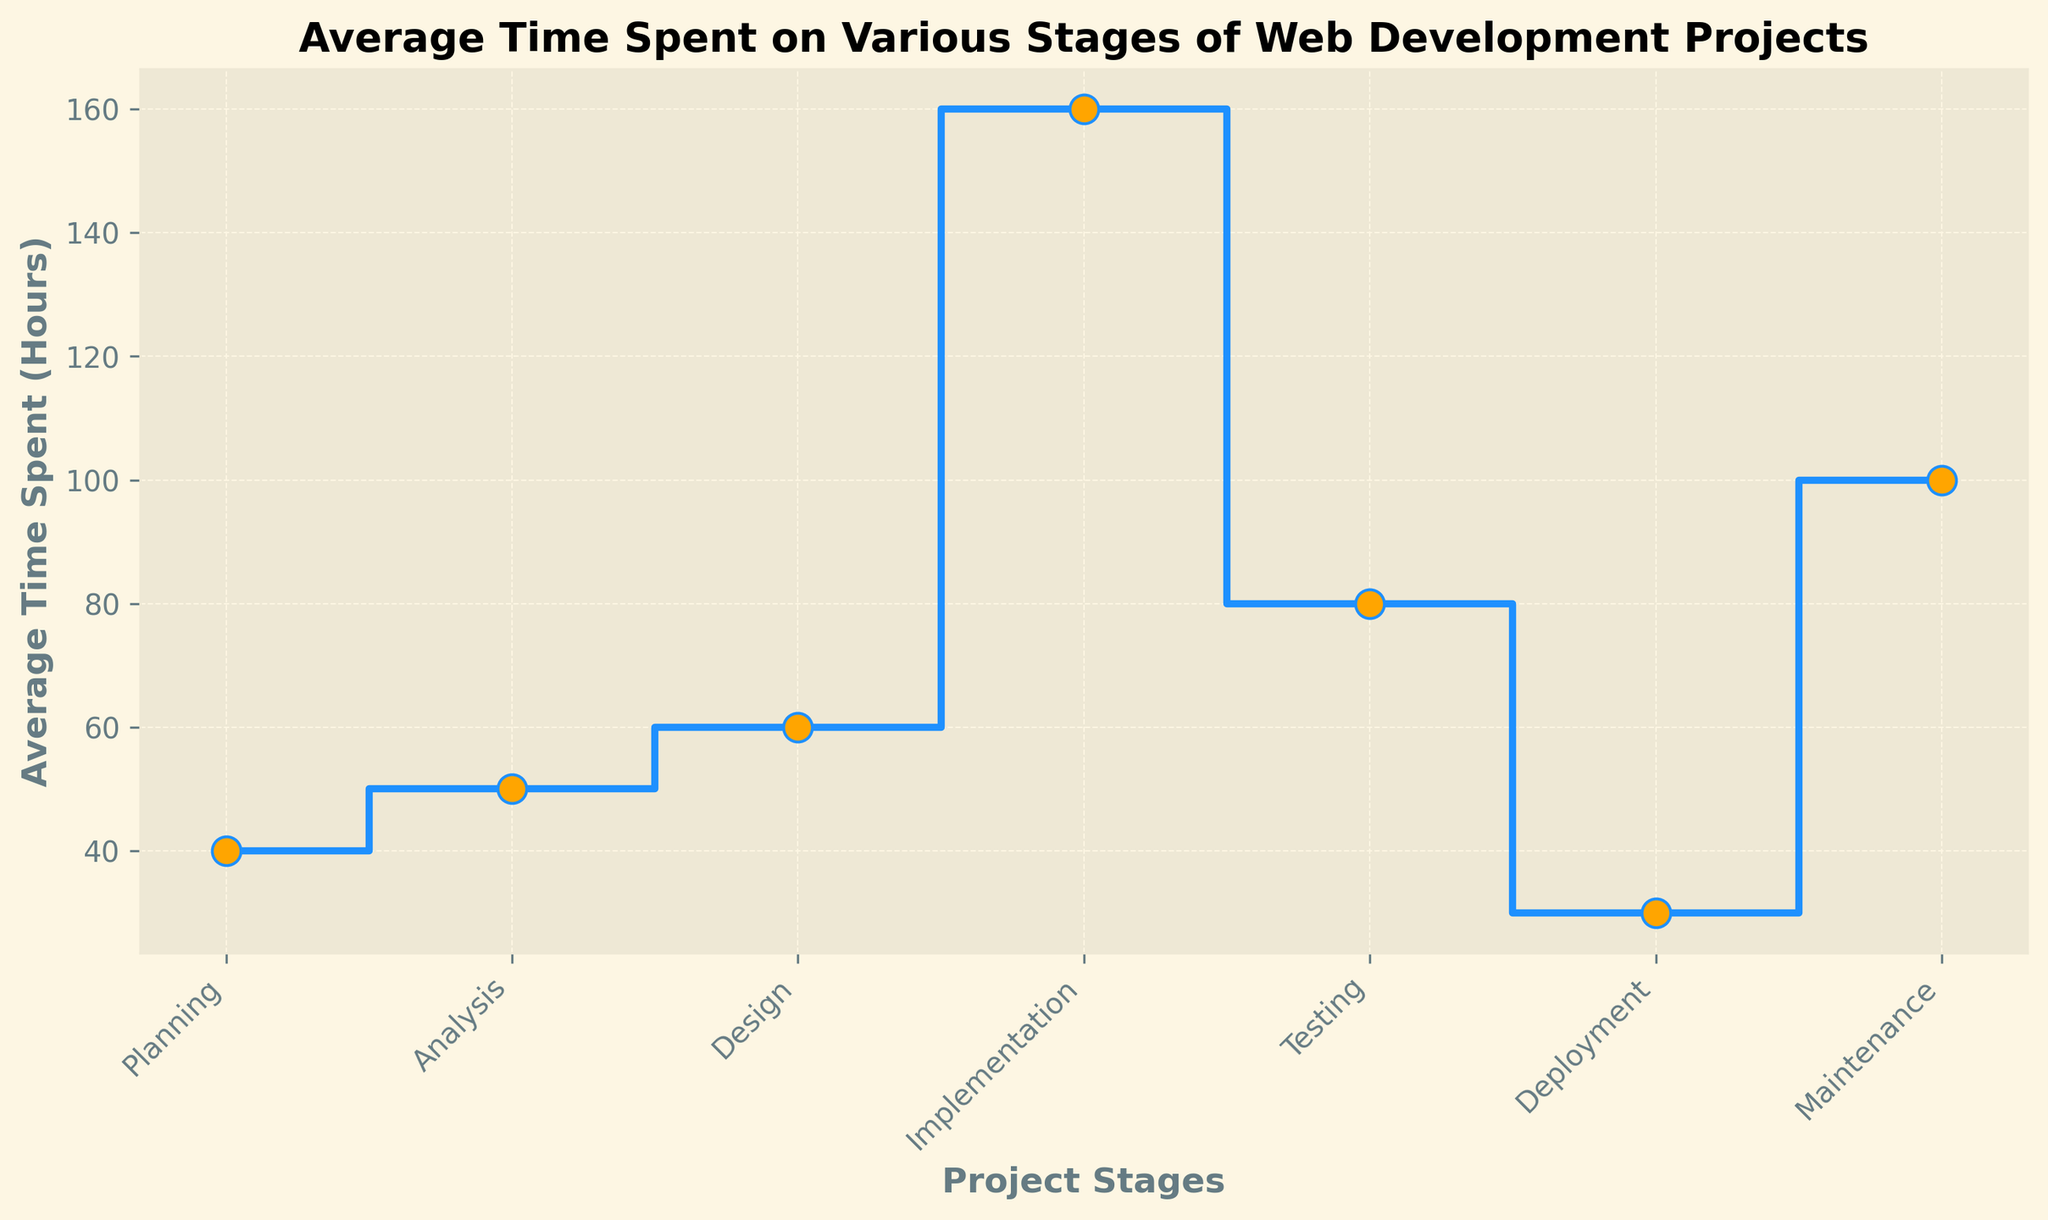What stage takes the longest average time? The stage taking the longest average time can be determined by identifying the highest value on the y-axis of the plot. The highest value corresponds to the 'Implementation' stage, which is 160 hours.
Answer: Implementation How much more time is spent on Implementation compared to Testing? To find the difference in time between 'Implementation' and 'Testing', subtract the average time of 'Testing' from 'Implementation'. This is 160 hours (Implementation) - 80 hours (Testing) = 80 hours.
Answer: 80 hours Which stages require less time than Maintenance? To determine stages that require less time than 'Maintenance', we compare their average times. Values less than 100 hours (Maintenance) are: Planning (40 hours), Analysis (50 hours), Design (60 hours), Implementation (160 hours - excluded), Testing (80 hours), and Deployment (30 hours). The stages are Planning, Analysis, Design, Testing, and Deployment.
Answer: Planning, Analysis, Design, Testing, Deployment What is the combined average time spent on Planning and Deployment? The combined average time is found by adding the times spent on 'Planning' and 'Deployment', which is 40 hours (Planning) + 30 hours (Deployment) = 70 hours.
Answer: 70 hours How does the time spent on Testing compare to the time spent on Design? Compare the average times directly. Testing takes 80 hours, while Design takes 60 hours. Therefore, Testing takes longer than Design.
Answer: Testing takes longer Which stage has the shortest average time? The stage with the shortest average time can be identified by spotting the lowest value on the y-axis of the plot. That stage is 'Deployment', with 30 hours.
Answer: Deployment What is the total average time spent from Planning to Deployment? Sum the average times for Planning, Analysis, Design, Implementation, Testing, and Deployment (excluding Maintenance). This is 40 + 50 + 60 + 160 + 80 + 30 = 420 hours.
Answer: 420 hours What percentage of the total time (from Planning to Maintenance) is spent on Implementation? Total time from Planning to Maintenance is 40 + 50 + 60 + 160 + 80 + 30 + 100 = 520 hours. The percentage spent on Implementation is (160 / 520) * 100 = 30.77%.
Answer: 30.77% Is the time spent on Maintenance more, less, or equal to the time spent on Testing and Deployment combined? Combine the average times of 'Testing' and 'Deployment': 80 + 30 = 110 hours. Compare it with the time spent on 'Maintenance' which is 100 hours. Since 100 < 110, Maintenance time is less than Testing and Deployment combined.
Answer: Less What is the difference between the average time spent on the shortest and longest stages? The shortest stage is Deployment (30 hours) and the longest is Implementation (160 hours). Difference is 160 - 30 = 130 hours.
Answer: 130 hours 